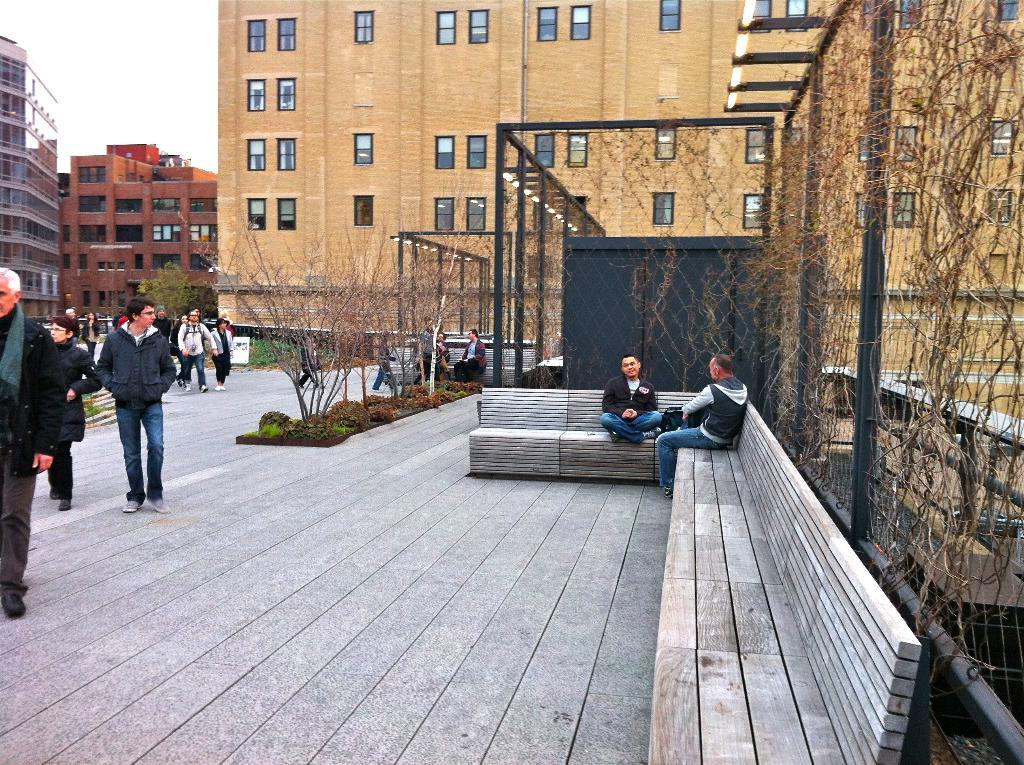What are the people in the image doing? In the image, some people are walking on the road, and some are sitting on benches. Can you describe the setting of the image? The image shows a group of people in a setting with a wall that has windows in the background and trees in the background. What type of ant can be seen carrying a vase in the image? There are no ants or vases present in the image. 